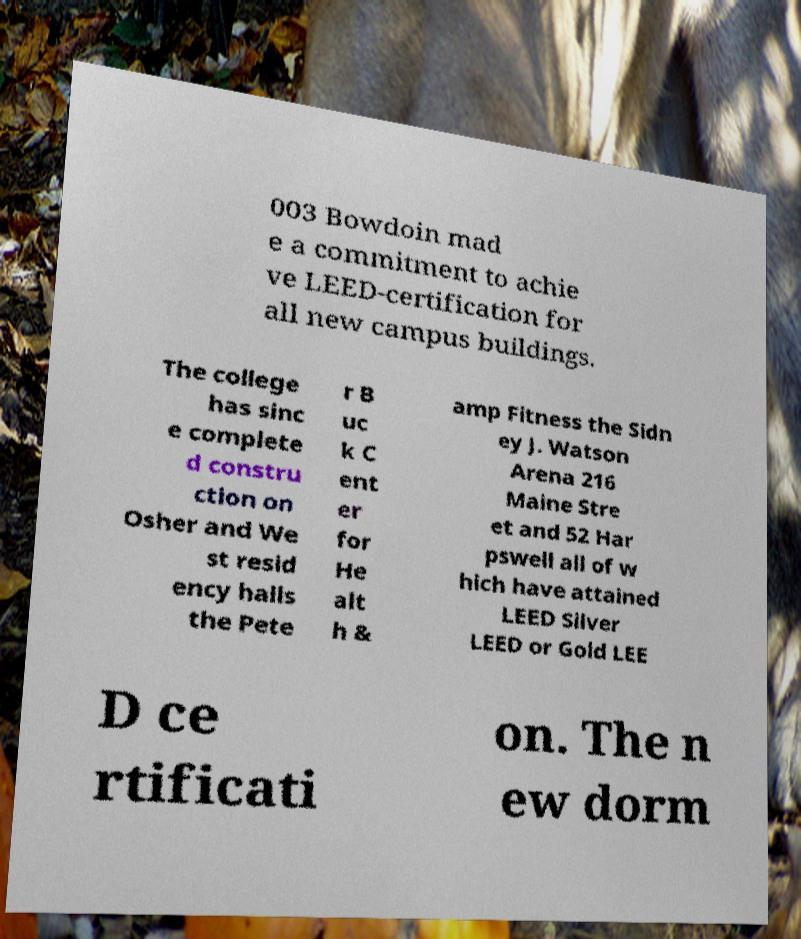Could you assist in decoding the text presented in this image and type it out clearly? 003 Bowdoin mad e a commitment to achie ve LEED-certification for all new campus buildings. The college has sinc e complete d constru ction on Osher and We st resid ency halls the Pete r B uc k C ent er for He alt h & amp Fitness the Sidn ey J. Watson Arena 216 Maine Stre et and 52 Har pswell all of w hich have attained LEED Silver LEED or Gold LEE D ce rtificati on. The n ew dorm 